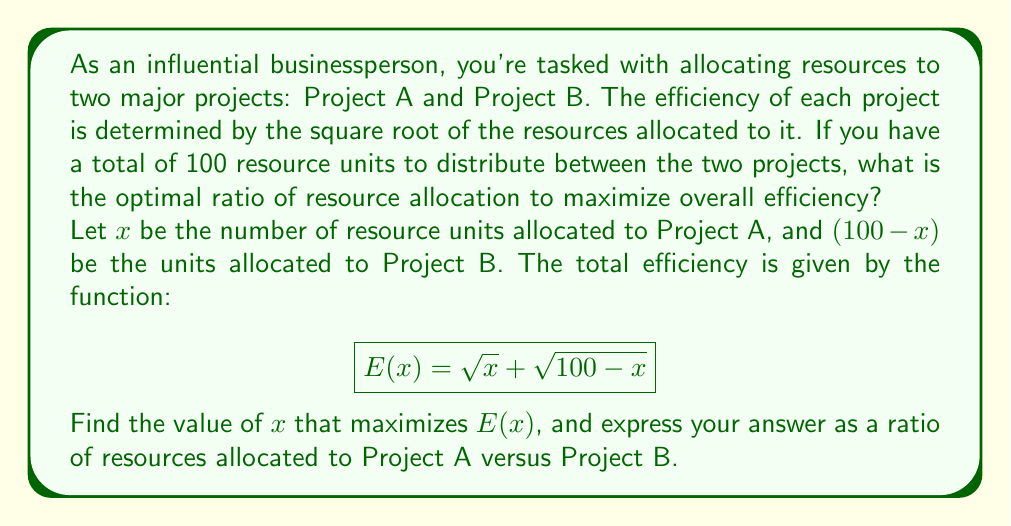Can you answer this question? To solve this problem, we'll follow these steps:

1) First, we need to find the maximum value of the function $E(x) = \sqrt{x} + \sqrt{100-x}$. This occurs when the derivative $E'(x)$ equals zero.

2) The derivative of $E(x)$ is:

   $$E'(x) = \frac{1}{2\sqrt{x}} - \frac{1}{2\sqrt{100-x}}$$

3) Setting this equal to zero:

   $$\frac{1}{2\sqrt{x}} - \frac{1}{2\sqrt{100-x}} = 0$$

4) Simplifying:

   $$\frac{1}{\sqrt{x}} = \frac{1}{\sqrt{100-x}}$$

5) Squaring both sides:

   $$\frac{1}{x} = \frac{1}{100-x}$$

6) Cross-multiplying:

   $$100-x = x$$

7) Solving for x:

   $$100 = 2x$$
   $$x = 50$$

8) This means that the optimal allocation is 50 units to Project A and 50 units to Project B.

9) To express this as a ratio, we divide both numbers by their greatest common divisor (which is 50):

   $$50:50 = 1:1$$

Therefore, the optimal ratio of resource allocation for maximum efficiency is 1:1.
Answer: The optimal ratio of resource allocation for maximum efficiency is 1:1. 